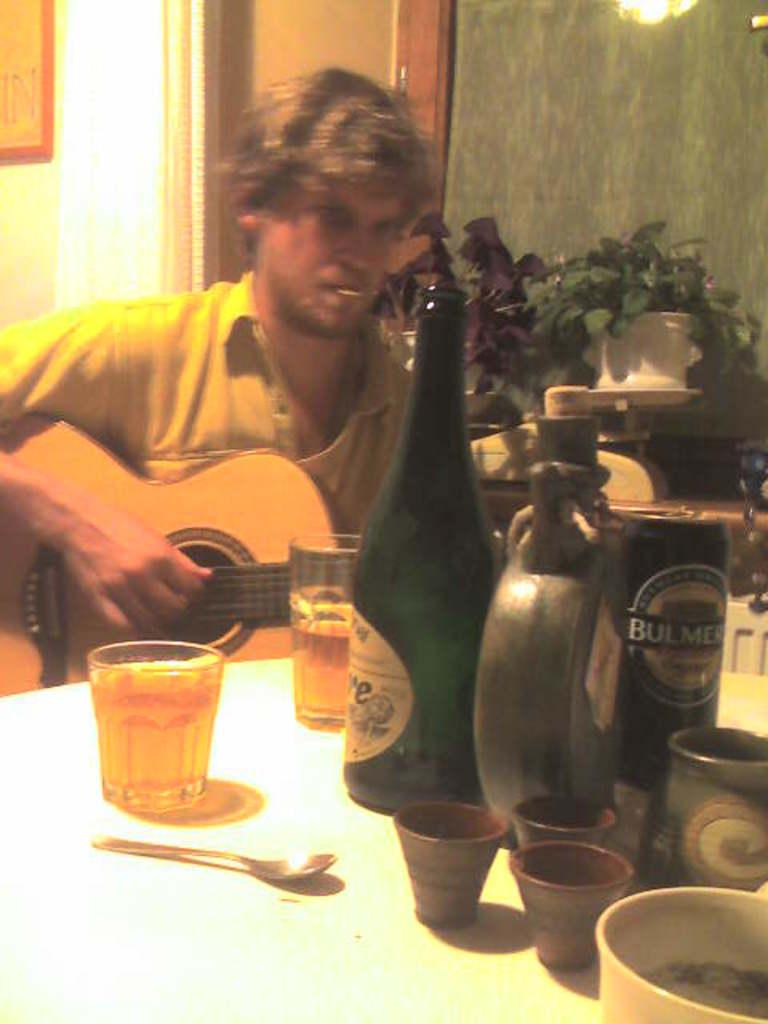Provide a one-sentence caption for the provided image. A man playing a guitar with a can of Bulmers on a table. 